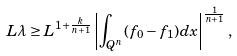<formula> <loc_0><loc_0><loc_500><loc_500>L \lambda \geq L ^ { 1 + \frac { k } { n + 1 } } \left | \int _ { Q ^ { n } } ( f _ { 0 } - f _ { 1 } ) d x \right | ^ { \frac { 1 } { n + 1 } } ,</formula> 